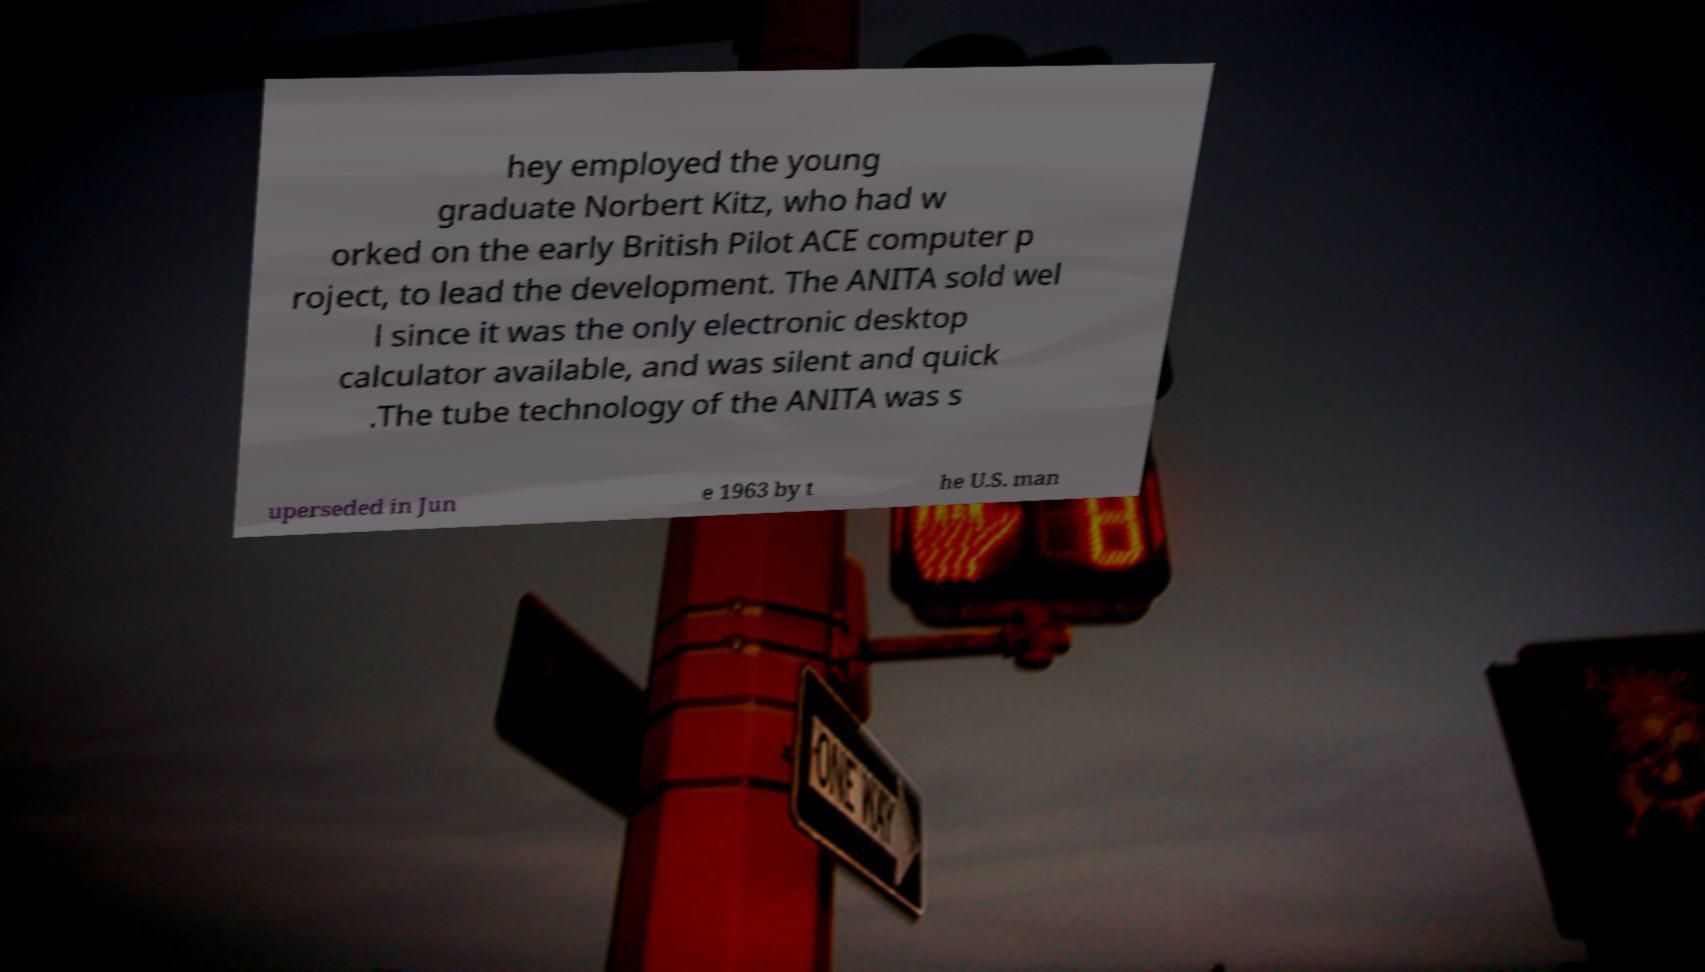Please identify and transcribe the text found in this image. hey employed the young graduate Norbert Kitz, who had w orked on the early British Pilot ACE computer p roject, to lead the development. The ANITA sold wel l since it was the only electronic desktop calculator available, and was silent and quick .The tube technology of the ANITA was s uperseded in Jun e 1963 by t he U.S. man 